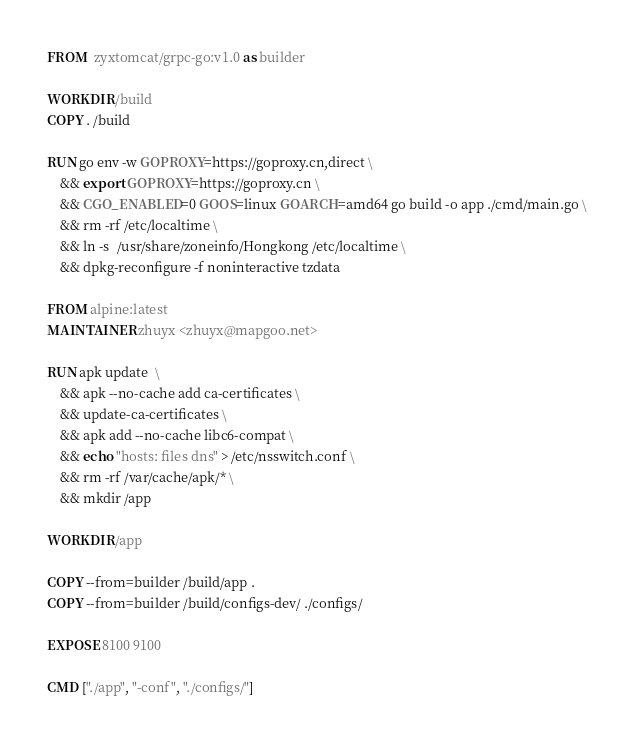Convert code to text. <code><loc_0><loc_0><loc_500><loc_500><_Dockerfile_>FROM  zyxtomcat/grpc-go:v1.0 as builder

WORKDIR /build
COPY . /build

RUN go env -w GOPROXY=https://goproxy.cn,direct \
    && export GOPROXY=https://goproxy.cn \
    && CGO_ENABLED=0 GOOS=linux GOARCH=amd64 go build -o app ./cmd/main.go \
    && rm -rf /etc/localtime \
    && ln -s  /usr/share/zoneinfo/Hongkong /etc/localtime \
    && dpkg-reconfigure -f noninteractive tzdata

FROM alpine:latest
MAINTAINER zhuyx <zhuyx@mapgoo.net>

RUN apk update  \
    && apk --no-cache add ca-certificates \
    && update-ca-certificates \
    && apk add --no-cache libc6-compat \
    && echo "hosts: files dns" > /etc/nsswitch.conf \
    && rm -rf /var/cache/apk/* \
    && mkdir /app

WORKDIR /app

COPY --from=builder /build/app .
COPY --from=builder /build/configs-dev/ ./configs/

EXPOSE 8100 9100

CMD ["./app", "-conf", "./configs/"]
</code> 